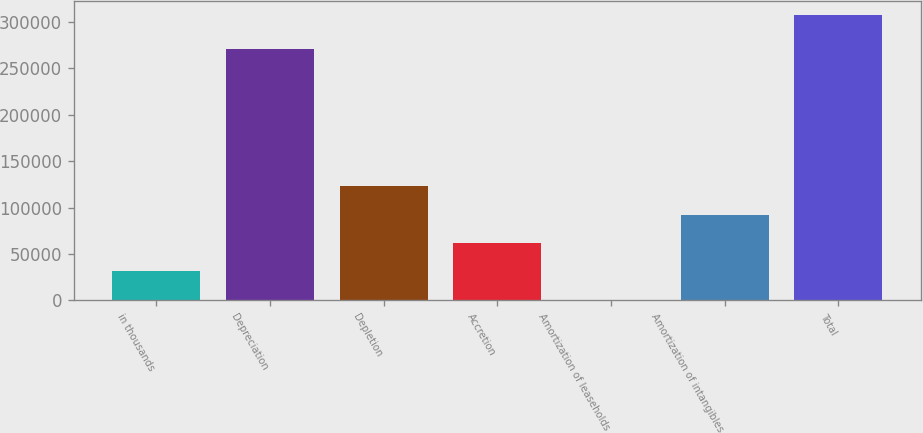Convert chart. <chart><loc_0><loc_0><loc_500><loc_500><bar_chart><fcel>in thousands<fcel>Depreciation<fcel>Depletion<fcel>Accretion<fcel>Amortization of leaseholds<fcel>Amortization of intangibles<fcel>Total<nl><fcel>31145.5<fcel>271180<fcel>123133<fcel>61808<fcel>483<fcel>92470.5<fcel>307108<nl></chart> 